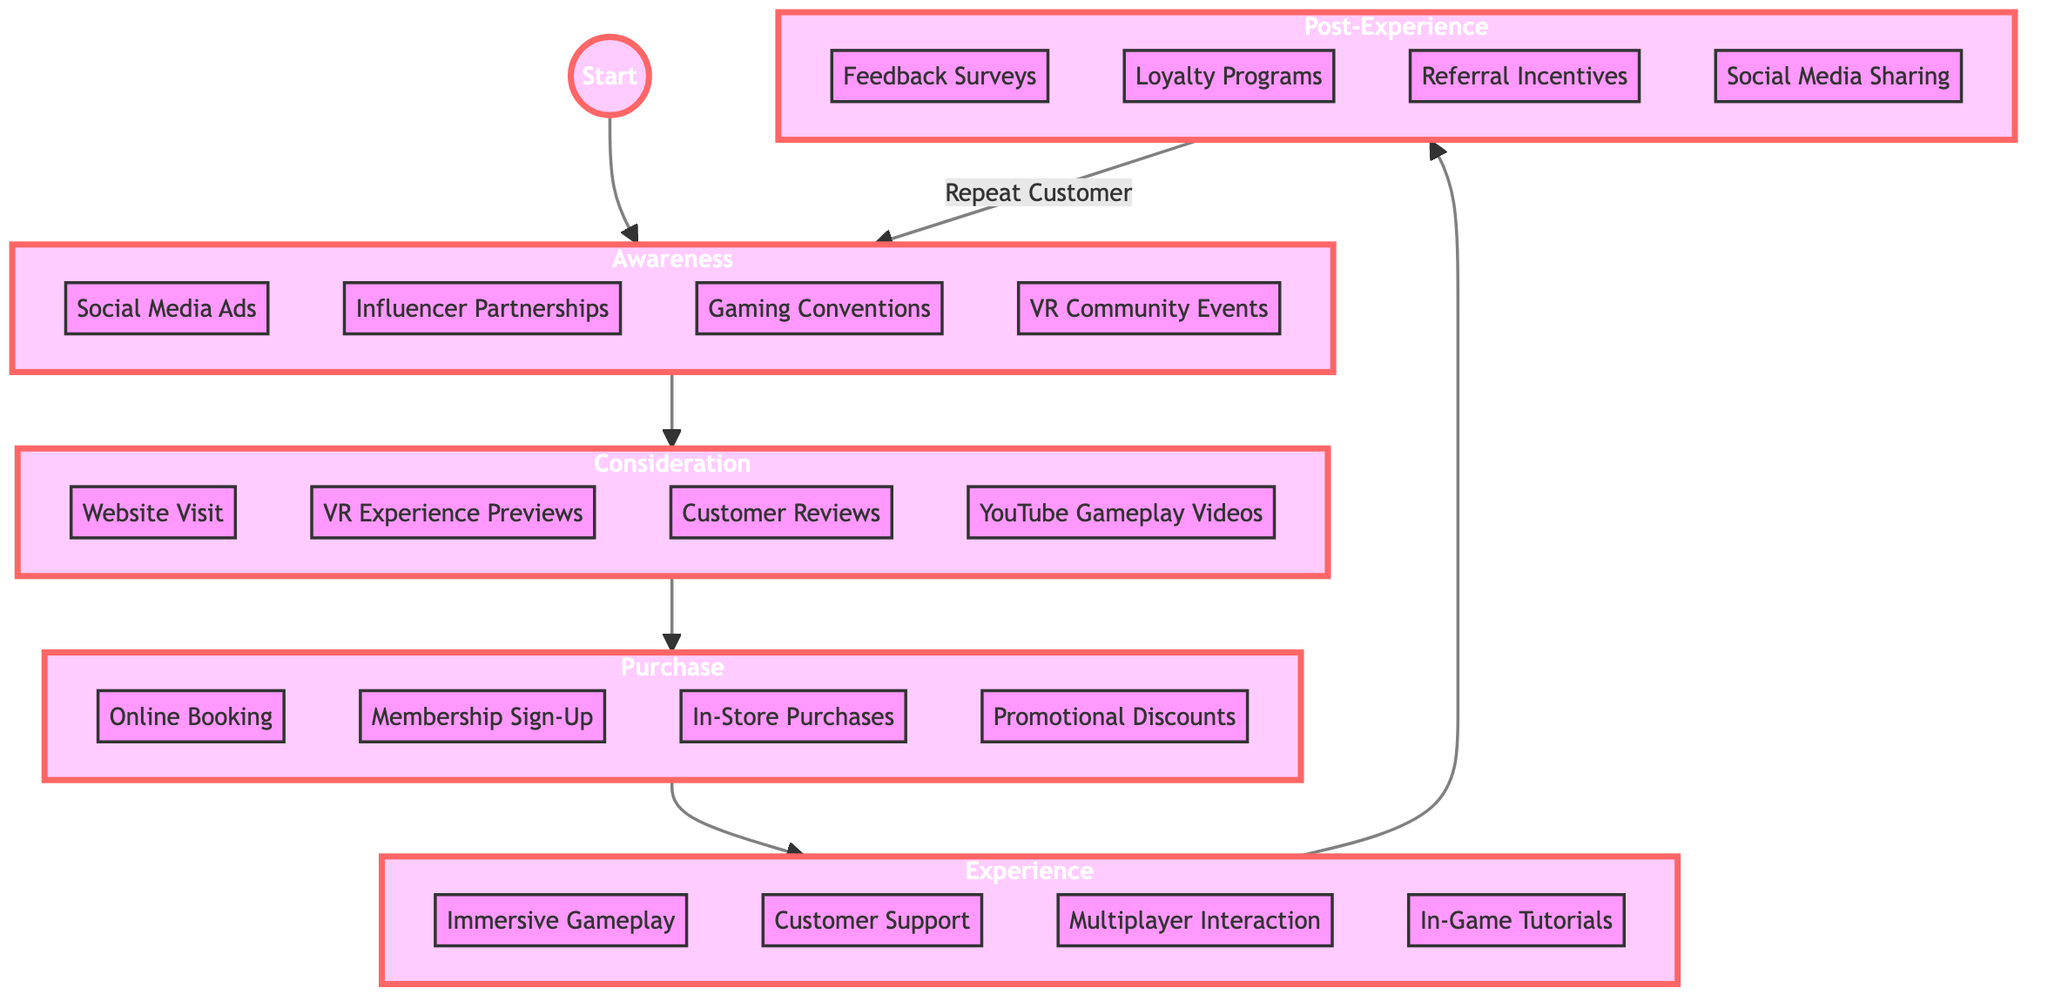What are the four channels in the Awareness stage? The Awareness stage includes the channels listed directly in the diagram: Social Media Ads, Influencer Partnerships, Gaming Conventions, and VR Community Events.
Answer: Social Media Ads, Influencer Partnerships, Gaming Conventions, VR Community Events How many touchpoints are there in the Consideration stage? In the Consideration stage, there are four touchpoints indicated in the diagram: Website Visit, VR Experience Previews, Customer Reviews, and YouTube Gameplay Videos. Counting these confirms there are four overall.
Answer: 4 What action follows Purchase in the flow? According to the flowchart, after the Purchase stage, the next action is the Experience stage. This is a direct sequential flow represented in the diagram.
Answer: Experience What are the key elements of the Experience stage? The Experience stage highlights four key elements: Immersive Gameplay, Customer Support, Multiplayer Interaction, and In-Game Tutorials, as laid out in the flowchart.
Answer: Immersive Gameplay, Customer Support, Multiplayer Interaction, In-Game Tutorials How do customers re-enter the journey after Post-Experience? After the Post-Experience stage, customers re-enter the journey through the Awareness stage as shown by the labeled arrow going back to Awareness in the diagram.
Answer: Awareness Which stage has customer engagement activities? The Post-Experience stage contains customer engagement activities, including Feedback Surveys, Loyalty Programs, Referral Incentives, and Social Media Sharing, as specified in the diagram.
Answer: Post-Experience Which touchpoint is not included in the Consideration stage? The touchpoint not included in the Consideration stage is any action from Purchase, as the stage specifically lists only the specified four (Website Visit, VR Experience Previews, Customer Reviews, and YouTube Gameplay Videos).
Answer: Purchase Which stage shows promotional actions? The Purchase stage displays promotional actions such as Online Booking, Membership Sign-Up, In-Store Purchases, and Promotional Discounts directly in the flowchart.
Answer: Purchase What is the total number of stages represented in the diagram? The diagram includes a total of five stages: Awareness, Consideration, Purchase, Experience, and Post-Experience, making a total of five distinct stages.
Answer: 5 